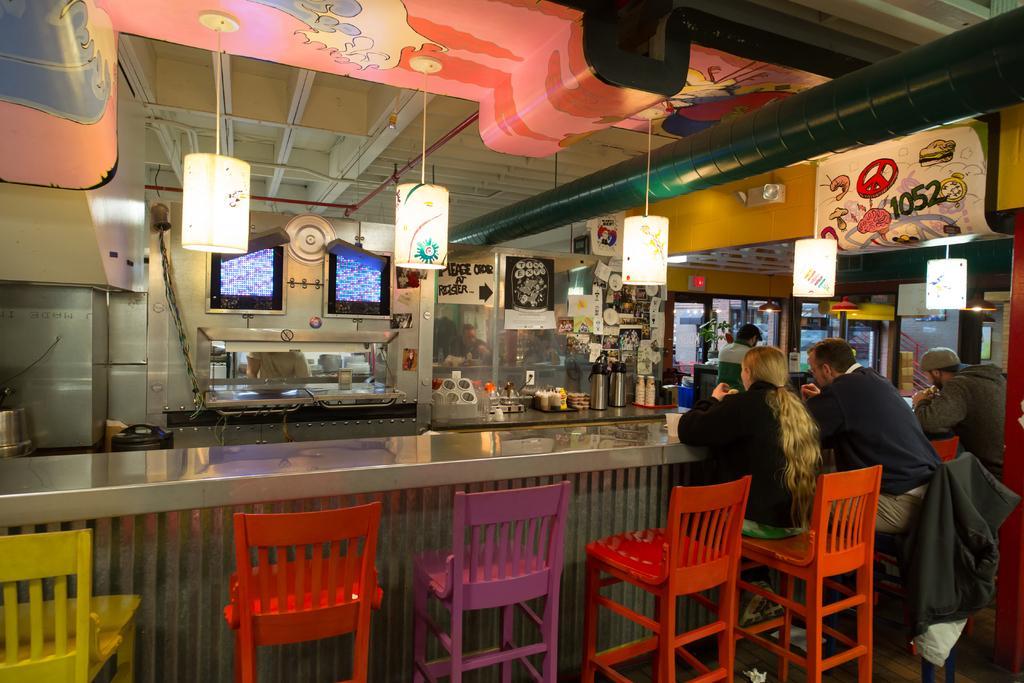How would you summarize this image in a sentence or two? In this image we can see inside of a store. There are few people are sitting on the chair near a table. There are many objects placed on the table. There are many lamps in the image. There is an entrance of the store in the image. 